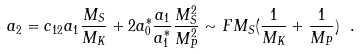<formula> <loc_0><loc_0><loc_500><loc_500>a _ { 2 } = c _ { 1 2 } a _ { 1 } \frac { M _ { S } } { M _ { K } } + 2 a _ { 0 } ^ { * } \frac { a _ { 1 } } { a _ { 1 } ^ { * } } \frac { M _ { S } ^ { 2 } } { M _ { P } ^ { 2 } } \sim F M _ { S } ( \frac { 1 } { M _ { K } } + \frac { 1 } { M _ { P } } ) \ .</formula> 